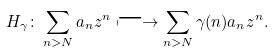<formula> <loc_0><loc_0><loc_500><loc_500>H _ { \gamma } \colon \sum _ { n > N } a _ { n } z ^ { n } \longmapsto \sum _ { n > N } \gamma ( n ) a _ { n } z ^ { n } .</formula> 